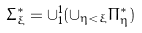Convert formula to latex. <formula><loc_0><loc_0><loc_500><loc_500>\Sigma ^ { * } _ { \xi } = \cup ^ { 1 } _ { 1 } ( \cup _ { \eta < \xi } \Pi ^ { * } _ { \eta } )</formula> 